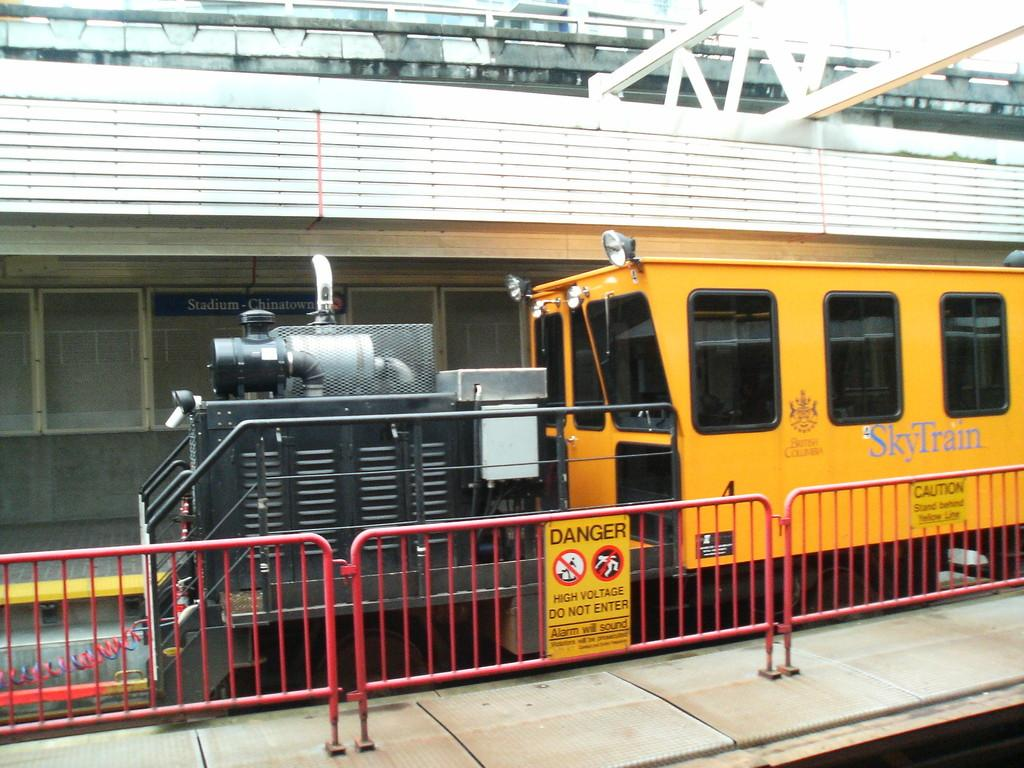What is the main subject of the image? The main subject of the image is a train. What is the train positioned on? The train is on tracks. Are there any additional objects or features near the train? Yes, there are sign boards on the fence beside the train. What type of pies can be seen on the train in the image? There are no pies visible on the train in the image. How many doors are present on the train in the image? The image does not show any doors on the train. 